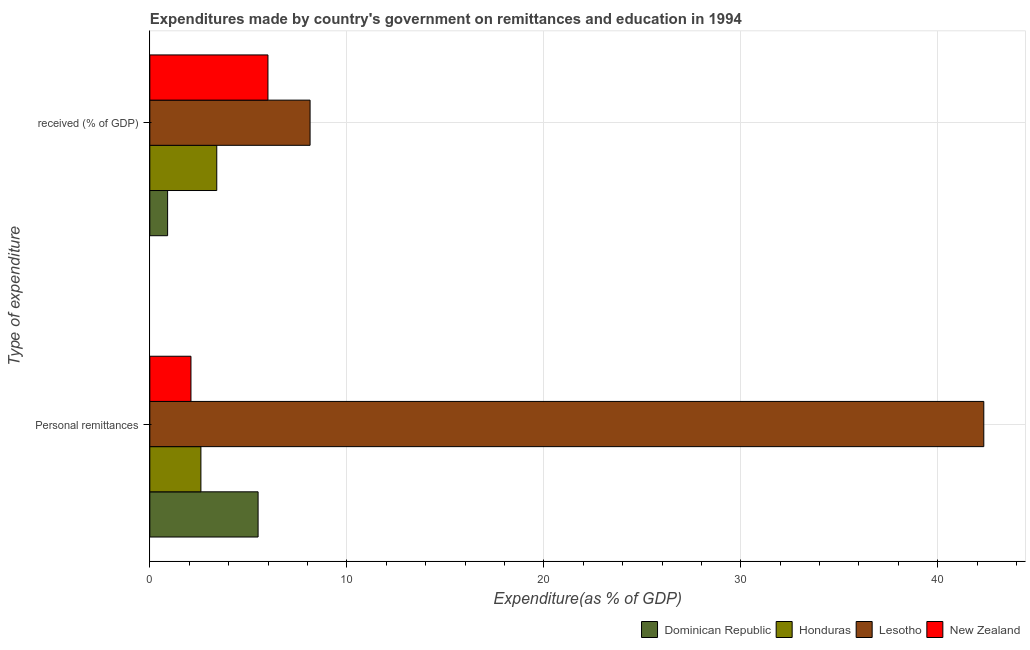How many different coloured bars are there?
Make the answer very short. 4. How many groups of bars are there?
Keep it short and to the point. 2. Are the number of bars on each tick of the Y-axis equal?
Your response must be concise. Yes. How many bars are there on the 2nd tick from the top?
Make the answer very short. 4. How many bars are there on the 2nd tick from the bottom?
Ensure brevity in your answer.  4. What is the label of the 2nd group of bars from the top?
Your answer should be very brief. Personal remittances. What is the expenditure in personal remittances in New Zealand?
Your response must be concise. 2.09. Across all countries, what is the maximum expenditure in education?
Offer a terse response. 8.14. Across all countries, what is the minimum expenditure in personal remittances?
Your answer should be very brief. 2.09. In which country was the expenditure in personal remittances maximum?
Offer a very short reply. Lesotho. In which country was the expenditure in personal remittances minimum?
Give a very brief answer. New Zealand. What is the total expenditure in personal remittances in the graph?
Offer a terse response. 52.51. What is the difference between the expenditure in education in Dominican Republic and that in Honduras?
Your response must be concise. -2.5. What is the difference between the expenditure in education in Honduras and the expenditure in personal remittances in Lesotho?
Make the answer very short. -38.94. What is the average expenditure in education per country?
Ensure brevity in your answer.  4.61. What is the difference between the expenditure in personal remittances and expenditure in education in Lesotho?
Your answer should be very brief. 34.2. In how many countries, is the expenditure in personal remittances greater than 20 %?
Ensure brevity in your answer.  1. What is the ratio of the expenditure in education in Lesotho to that in New Zealand?
Make the answer very short. 1.36. Is the expenditure in education in Honduras less than that in Dominican Republic?
Provide a short and direct response. No. In how many countries, is the expenditure in personal remittances greater than the average expenditure in personal remittances taken over all countries?
Make the answer very short. 1. What does the 4th bar from the top in Personal remittances represents?
Your answer should be compact. Dominican Republic. What does the 2nd bar from the bottom in Personal remittances represents?
Provide a short and direct response. Honduras. Are all the bars in the graph horizontal?
Your answer should be compact. Yes. What is the difference between two consecutive major ticks on the X-axis?
Your answer should be very brief. 10. Are the values on the major ticks of X-axis written in scientific E-notation?
Give a very brief answer. No. Does the graph contain any zero values?
Offer a terse response. No. Where does the legend appear in the graph?
Offer a terse response. Bottom right. How many legend labels are there?
Ensure brevity in your answer.  4. What is the title of the graph?
Offer a very short reply. Expenditures made by country's government on remittances and education in 1994. Does "San Marino" appear as one of the legend labels in the graph?
Keep it short and to the point. No. What is the label or title of the X-axis?
Your answer should be very brief. Expenditure(as % of GDP). What is the label or title of the Y-axis?
Make the answer very short. Type of expenditure. What is the Expenditure(as % of GDP) in Dominican Republic in Personal remittances?
Give a very brief answer. 5.5. What is the Expenditure(as % of GDP) in Honduras in Personal remittances?
Make the answer very short. 2.59. What is the Expenditure(as % of GDP) in Lesotho in Personal remittances?
Offer a very short reply. 42.34. What is the Expenditure(as % of GDP) of New Zealand in Personal remittances?
Give a very brief answer. 2.09. What is the Expenditure(as % of GDP) in Dominican Republic in  received (% of GDP)?
Ensure brevity in your answer.  0.9. What is the Expenditure(as % of GDP) of Honduras in  received (% of GDP)?
Provide a short and direct response. 3.4. What is the Expenditure(as % of GDP) of Lesotho in  received (% of GDP)?
Your answer should be very brief. 8.14. What is the Expenditure(as % of GDP) of New Zealand in  received (% of GDP)?
Your response must be concise. 6. Across all Type of expenditure, what is the maximum Expenditure(as % of GDP) of Dominican Republic?
Provide a succinct answer. 5.5. Across all Type of expenditure, what is the maximum Expenditure(as % of GDP) of Honduras?
Your answer should be compact. 3.4. Across all Type of expenditure, what is the maximum Expenditure(as % of GDP) of Lesotho?
Provide a short and direct response. 42.34. Across all Type of expenditure, what is the maximum Expenditure(as % of GDP) in New Zealand?
Make the answer very short. 6. Across all Type of expenditure, what is the minimum Expenditure(as % of GDP) in Dominican Republic?
Provide a succinct answer. 0.9. Across all Type of expenditure, what is the minimum Expenditure(as % of GDP) of Honduras?
Your response must be concise. 2.59. Across all Type of expenditure, what is the minimum Expenditure(as % of GDP) of Lesotho?
Provide a short and direct response. 8.14. Across all Type of expenditure, what is the minimum Expenditure(as % of GDP) in New Zealand?
Make the answer very short. 2.09. What is the total Expenditure(as % of GDP) in Dominican Republic in the graph?
Keep it short and to the point. 6.4. What is the total Expenditure(as % of GDP) in Honduras in the graph?
Your answer should be very brief. 5.99. What is the total Expenditure(as % of GDP) of Lesotho in the graph?
Make the answer very short. 50.47. What is the total Expenditure(as % of GDP) of New Zealand in the graph?
Ensure brevity in your answer.  8.08. What is the difference between the Expenditure(as % of GDP) of Dominican Republic in Personal remittances and that in  received (% of GDP)?
Ensure brevity in your answer.  4.59. What is the difference between the Expenditure(as % of GDP) of Honduras in Personal remittances and that in  received (% of GDP)?
Make the answer very short. -0.81. What is the difference between the Expenditure(as % of GDP) of Lesotho in Personal remittances and that in  received (% of GDP)?
Your answer should be compact. 34.2. What is the difference between the Expenditure(as % of GDP) of New Zealand in Personal remittances and that in  received (% of GDP)?
Offer a terse response. -3.91. What is the difference between the Expenditure(as % of GDP) of Dominican Republic in Personal remittances and the Expenditure(as % of GDP) of Honduras in  received (% of GDP)?
Give a very brief answer. 2.1. What is the difference between the Expenditure(as % of GDP) of Dominican Republic in Personal remittances and the Expenditure(as % of GDP) of Lesotho in  received (% of GDP)?
Give a very brief answer. -2.64. What is the difference between the Expenditure(as % of GDP) in Dominican Republic in Personal remittances and the Expenditure(as % of GDP) in New Zealand in  received (% of GDP)?
Offer a terse response. -0.5. What is the difference between the Expenditure(as % of GDP) of Honduras in Personal remittances and the Expenditure(as % of GDP) of Lesotho in  received (% of GDP)?
Offer a very short reply. -5.54. What is the difference between the Expenditure(as % of GDP) of Honduras in Personal remittances and the Expenditure(as % of GDP) of New Zealand in  received (% of GDP)?
Ensure brevity in your answer.  -3.4. What is the difference between the Expenditure(as % of GDP) in Lesotho in Personal remittances and the Expenditure(as % of GDP) in New Zealand in  received (% of GDP)?
Give a very brief answer. 36.34. What is the average Expenditure(as % of GDP) in Dominican Republic per Type of expenditure?
Your answer should be compact. 3.2. What is the average Expenditure(as % of GDP) of Honduras per Type of expenditure?
Make the answer very short. 3. What is the average Expenditure(as % of GDP) in Lesotho per Type of expenditure?
Make the answer very short. 25.24. What is the average Expenditure(as % of GDP) in New Zealand per Type of expenditure?
Provide a succinct answer. 4.04. What is the difference between the Expenditure(as % of GDP) of Dominican Republic and Expenditure(as % of GDP) of Honduras in Personal remittances?
Your answer should be very brief. 2.9. What is the difference between the Expenditure(as % of GDP) in Dominican Republic and Expenditure(as % of GDP) in Lesotho in Personal remittances?
Make the answer very short. -36.84. What is the difference between the Expenditure(as % of GDP) in Dominican Republic and Expenditure(as % of GDP) in New Zealand in Personal remittances?
Offer a terse response. 3.41. What is the difference between the Expenditure(as % of GDP) of Honduras and Expenditure(as % of GDP) of Lesotho in Personal remittances?
Offer a very short reply. -39.74. What is the difference between the Expenditure(as % of GDP) in Honduras and Expenditure(as % of GDP) in New Zealand in Personal remittances?
Make the answer very short. 0.51. What is the difference between the Expenditure(as % of GDP) in Lesotho and Expenditure(as % of GDP) in New Zealand in Personal remittances?
Offer a terse response. 40.25. What is the difference between the Expenditure(as % of GDP) of Dominican Republic and Expenditure(as % of GDP) of Honduras in  received (% of GDP)?
Provide a succinct answer. -2.5. What is the difference between the Expenditure(as % of GDP) in Dominican Republic and Expenditure(as % of GDP) in Lesotho in  received (% of GDP)?
Provide a succinct answer. -7.23. What is the difference between the Expenditure(as % of GDP) in Dominican Republic and Expenditure(as % of GDP) in New Zealand in  received (% of GDP)?
Ensure brevity in your answer.  -5.09. What is the difference between the Expenditure(as % of GDP) of Honduras and Expenditure(as % of GDP) of Lesotho in  received (% of GDP)?
Provide a short and direct response. -4.74. What is the difference between the Expenditure(as % of GDP) in Honduras and Expenditure(as % of GDP) in New Zealand in  received (% of GDP)?
Ensure brevity in your answer.  -2.6. What is the difference between the Expenditure(as % of GDP) in Lesotho and Expenditure(as % of GDP) in New Zealand in  received (% of GDP)?
Provide a short and direct response. 2.14. What is the ratio of the Expenditure(as % of GDP) in Dominican Republic in Personal remittances to that in  received (% of GDP)?
Your response must be concise. 6.09. What is the ratio of the Expenditure(as % of GDP) of Honduras in Personal remittances to that in  received (% of GDP)?
Make the answer very short. 0.76. What is the ratio of the Expenditure(as % of GDP) of Lesotho in Personal remittances to that in  received (% of GDP)?
Provide a succinct answer. 5.2. What is the ratio of the Expenditure(as % of GDP) of New Zealand in Personal remittances to that in  received (% of GDP)?
Keep it short and to the point. 0.35. What is the difference between the highest and the second highest Expenditure(as % of GDP) of Dominican Republic?
Offer a very short reply. 4.59. What is the difference between the highest and the second highest Expenditure(as % of GDP) in Honduras?
Your answer should be compact. 0.81. What is the difference between the highest and the second highest Expenditure(as % of GDP) in Lesotho?
Give a very brief answer. 34.2. What is the difference between the highest and the second highest Expenditure(as % of GDP) in New Zealand?
Keep it short and to the point. 3.91. What is the difference between the highest and the lowest Expenditure(as % of GDP) in Dominican Republic?
Your answer should be very brief. 4.59. What is the difference between the highest and the lowest Expenditure(as % of GDP) in Honduras?
Your answer should be compact. 0.81. What is the difference between the highest and the lowest Expenditure(as % of GDP) of Lesotho?
Offer a very short reply. 34.2. What is the difference between the highest and the lowest Expenditure(as % of GDP) of New Zealand?
Give a very brief answer. 3.91. 